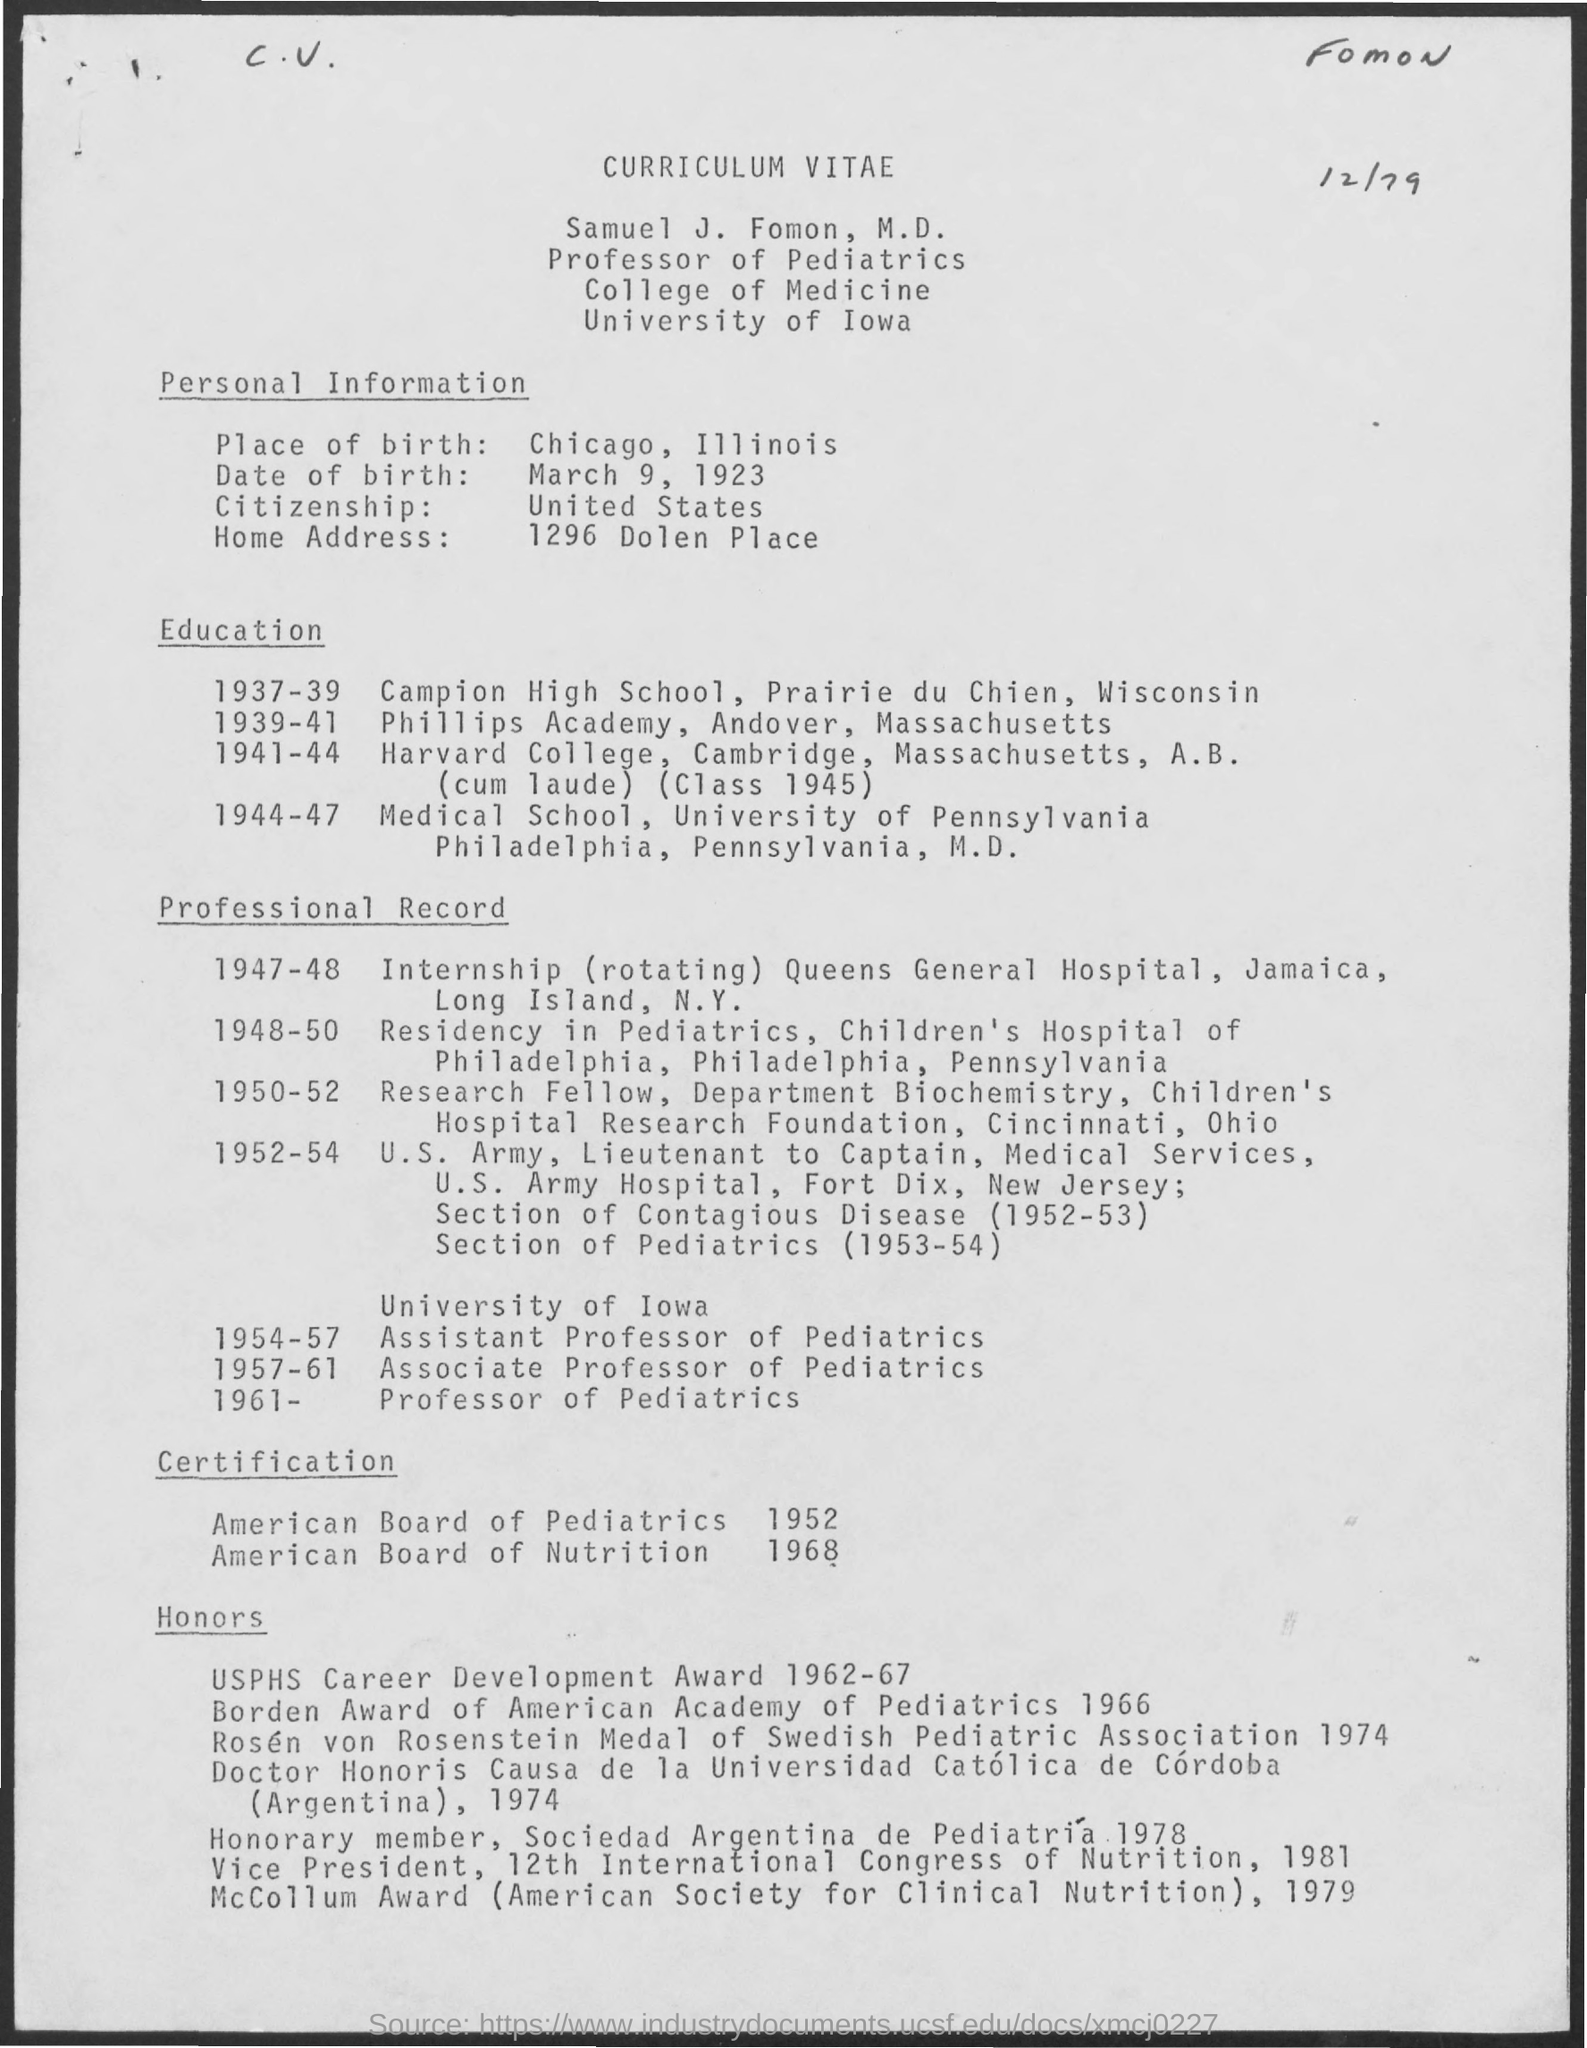Indicate a few pertinent items in this graphic. Samuel J. Fomon, M.D., is a citizen of the United States. Samuel J. Fomon, M.D. was born on March 9, 1923. Samuel J. Fomon, M.D. worked as a Residency in Pediatrics during the period of 1948-1950. Samuel J. Fomon, M.D. received certification from the American Board of Pediatrics in 1952. Samuel J. Fomon, M.D., works at the University of Iowa. 